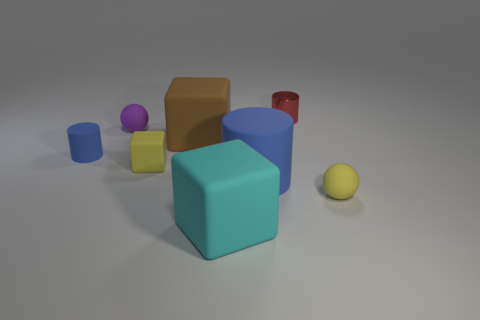There is a rubber ball on the right side of the red metallic thing; is it the same color as the small block?
Your response must be concise. Yes. How many brown things are the same size as the red cylinder?
Provide a succinct answer. 0. Are there fewer tiny matte spheres behind the small yellow block than cylinders that are left of the small metallic cylinder?
Keep it short and to the point. Yes. What number of rubber things are either small yellow spheres or small things?
Keep it short and to the point. 4. What is the shape of the brown rubber object?
Your answer should be very brief. Cube. There is a cube that is the same size as the cyan matte object; what is it made of?
Offer a very short reply. Rubber. How many small things are blue metallic cylinders or purple matte balls?
Give a very brief answer. 1. Is there a tiny rubber ball?
Ensure brevity in your answer.  Yes. What is the size of the brown thing that is made of the same material as the small purple ball?
Your answer should be very brief. Large. Does the large brown thing have the same material as the small yellow ball?
Make the answer very short. Yes. 